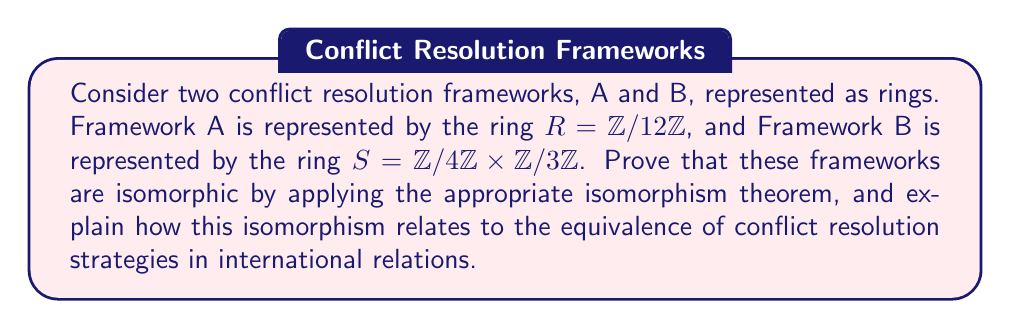Give your solution to this math problem. To prove that the two rings $R = \mathbb{Z}/12\mathbb{Z}$ and $S = \mathbb{Z}/4\mathbb{Z} \times \mathbb{Z}/3\mathbb{Z}$ are isomorphic, we can apply the Chinese Remainder Theorem, which is a special case of the First Isomorphism Theorem.

Step 1: Verify the conditions for the Chinese Remainder Theorem
The Chinese Remainder Theorem states that if $n_1$ and $n_2$ are coprime positive integers, then:

$\mathbb{Z}/n_1n_2\mathbb{Z} \cong \mathbb{Z}/n_1\mathbb{Z} \times \mathbb{Z}/n_2\mathbb{Z}$

In our case, $n_1 = 4$ and $n_2 = 3$. We can see that 4 and 3 are coprime, and $4 \times 3 = 12$.

Step 2: Apply the theorem
Since the conditions are met, we can directly apply the Chinese Remainder Theorem:

$\mathbb{Z}/12\mathbb{Z} \cong \mathbb{Z}/4\mathbb{Z} \times \mathbb{Z}/3\mathbb{Z}$

This proves that $R \cong S$, demonstrating that the two rings are isomorphic.

Step 3: Construct the isomorphism
The isomorphism $\phi: R \to S$ can be defined as:

$\phi([x]_{12}) = ([x \bmod 4]_4, [x \bmod 3]_3)$

The inverse map $\phi^{-1}: S \to R$ can be constructed using the Chinese Remainder Theorem:

$\phi^{-1}([a]_4, [b]_3) = [4^{-1}_3 \cdot 3 \cdot a + 3^{-1}_4 \cdot 4 \cdot b]_{12}$

Where $4^{-1}_3 = 1$ and $3^{-1}_4 = 3$.

Interpretation in conflict resolution context:
This isomorphism demonstrates that the two conflict resolution frameworks, A and B, are structurally equivalent. In the context of international relations:

1. Framework A ($\mathbb{Z}/12\mathbb{Z}$) might represent a unified approach with 12 distinct strategies or stages in conflict resolution.

2. Framework B ($\mathbb{Z}/4\mathbb{Z} \times \mathbb{Z}/3\mathbb{Z}$) could represent a two-dimensional approach, with 4 main categories of strategies and 3 sub-strategies within each category.

The isomorphism proves that these frameworks are equivalent and can be transformed into each other without loss of information. This suggests that international organizations can use either framework interchangeably, choosing the one that best fits their operational structure or the specific conflict at hand, while still maintaining the same underlying principles and effectiveness in conflict resolution.
Answer: The rings $R = \mathbb{Z}/12\mathbb{Z}$ and $S = \mathbb{Z}/4\mathbb{Z} \times \mathbb{Z}/3\mathbb{Z}$ are isomorphic. The isomorphism $\phi: R \to S$ is given by $\phi([x]_{12}) = ([x \bmod 4]_4, [x \bmod 3]_3)$, and its inverse is $\phi^{-1}([a]_4, [b]_3) = [3a + 4b]_{12}$. This isomorphism demonstrates the structural equivalence of the two conflict resolution frameworks in international relations. 